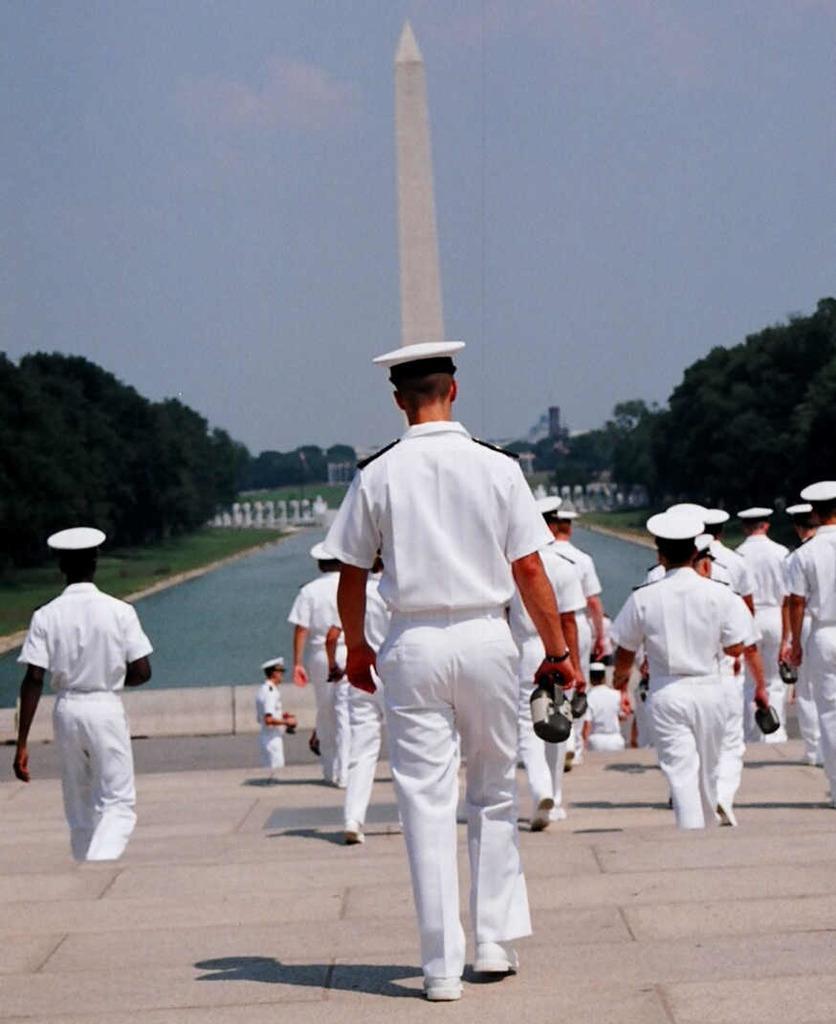In one or two sentences, can you explain what this image depicts? In the center of the image we can see a group of persons walking on the stairs. In the background there is a tower, trees, water and sky. 